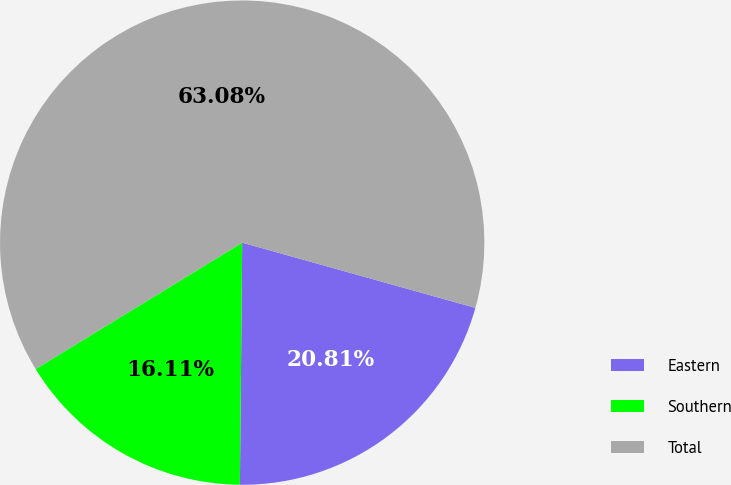Convert chart. <chart><loc_0><loc_0><loc_500><loc_500><pie_chart><fcel>Eastern<fcel>Southern<fcel>Total<nl><fcel>20.81%<fcel>16.11%<fcel>63.08%<nl></chart> 